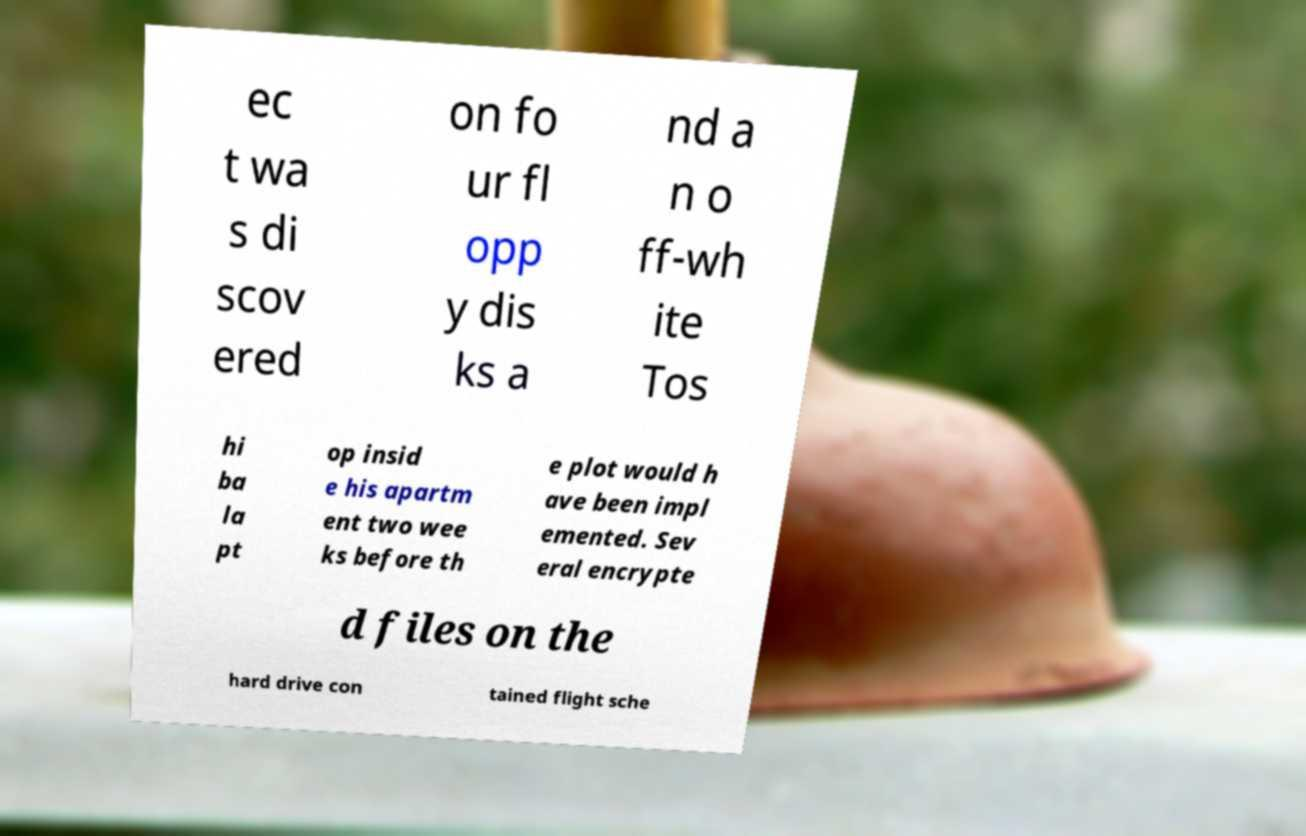Can you accurately transcribe the text from the provided image for me? ec t wa s di scov ered on fo ur fl opp y dis ks a nd a n o ff-wh ite Tos hi ba la pt op insid e his apartm ent two wee ks before th e plot would h ave been impl emented. Sev eral encrypte d files on the hard drive con tained flight sche 